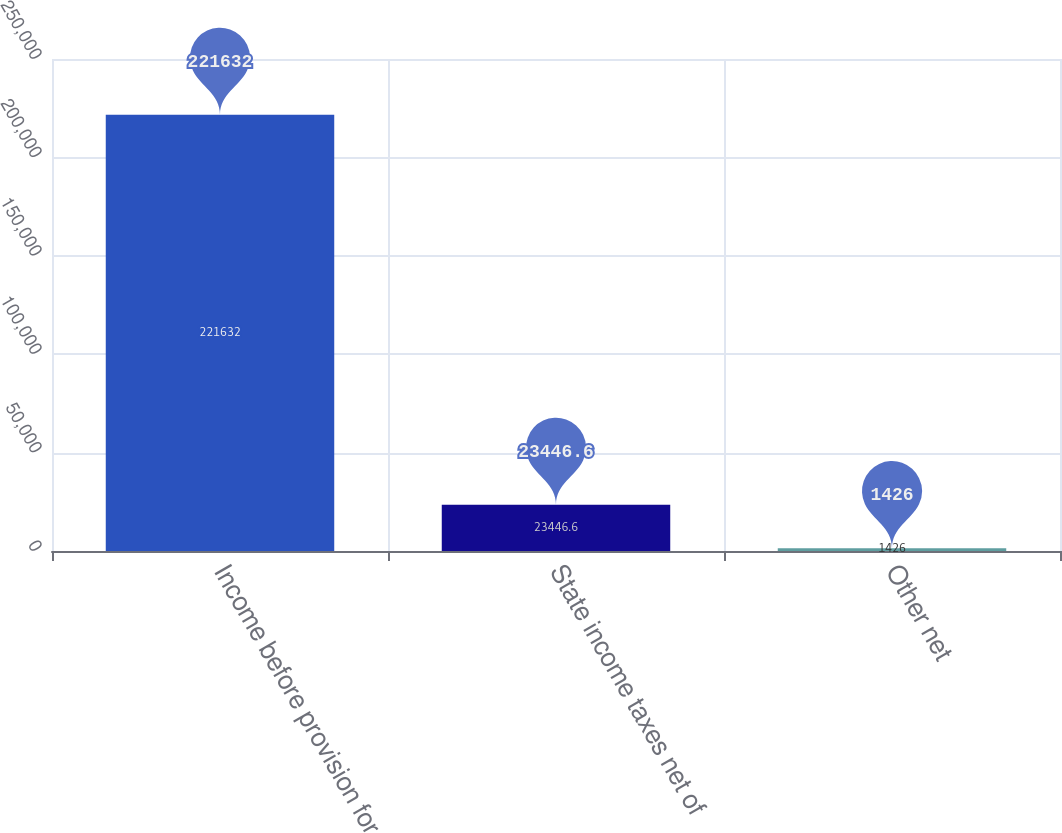<chart> <loc_0><loc_0><loc_500><loc_500><bar_chart><fcel>Income before provision for<fcel>State income taxes net of<fcel>Other net<nl><fcel>221632<fcel>23446.6<fcel>1426<nl></chart> 